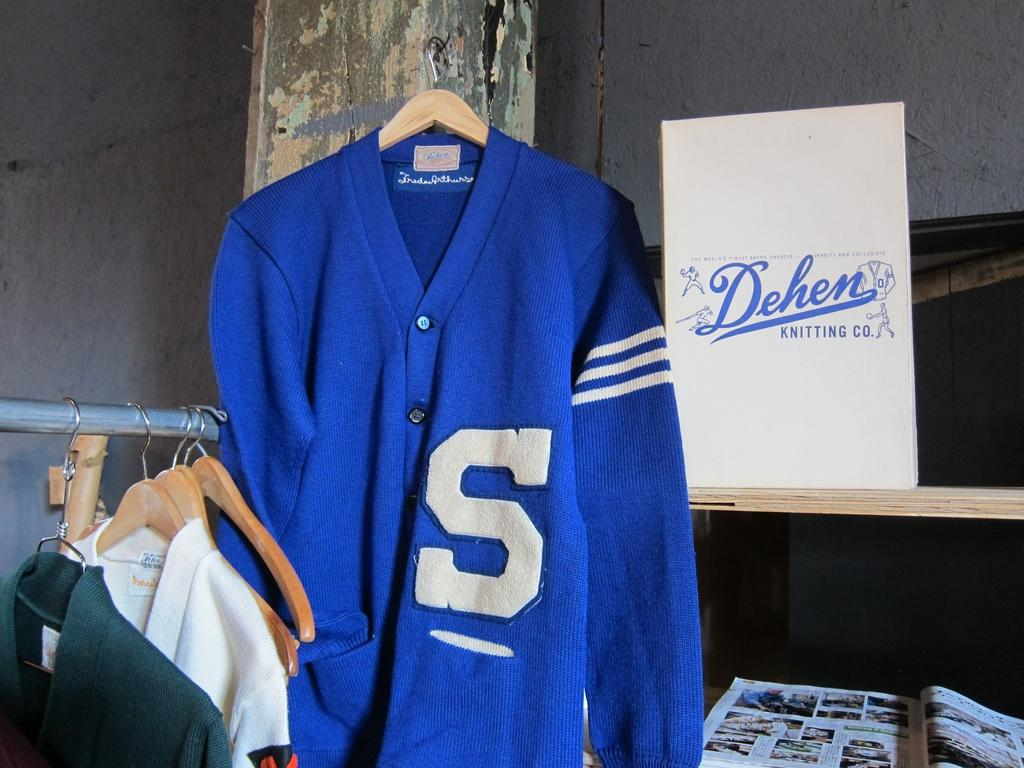<image>
Present a compact description of the photo's key features. a jacket that has the letter S on it 